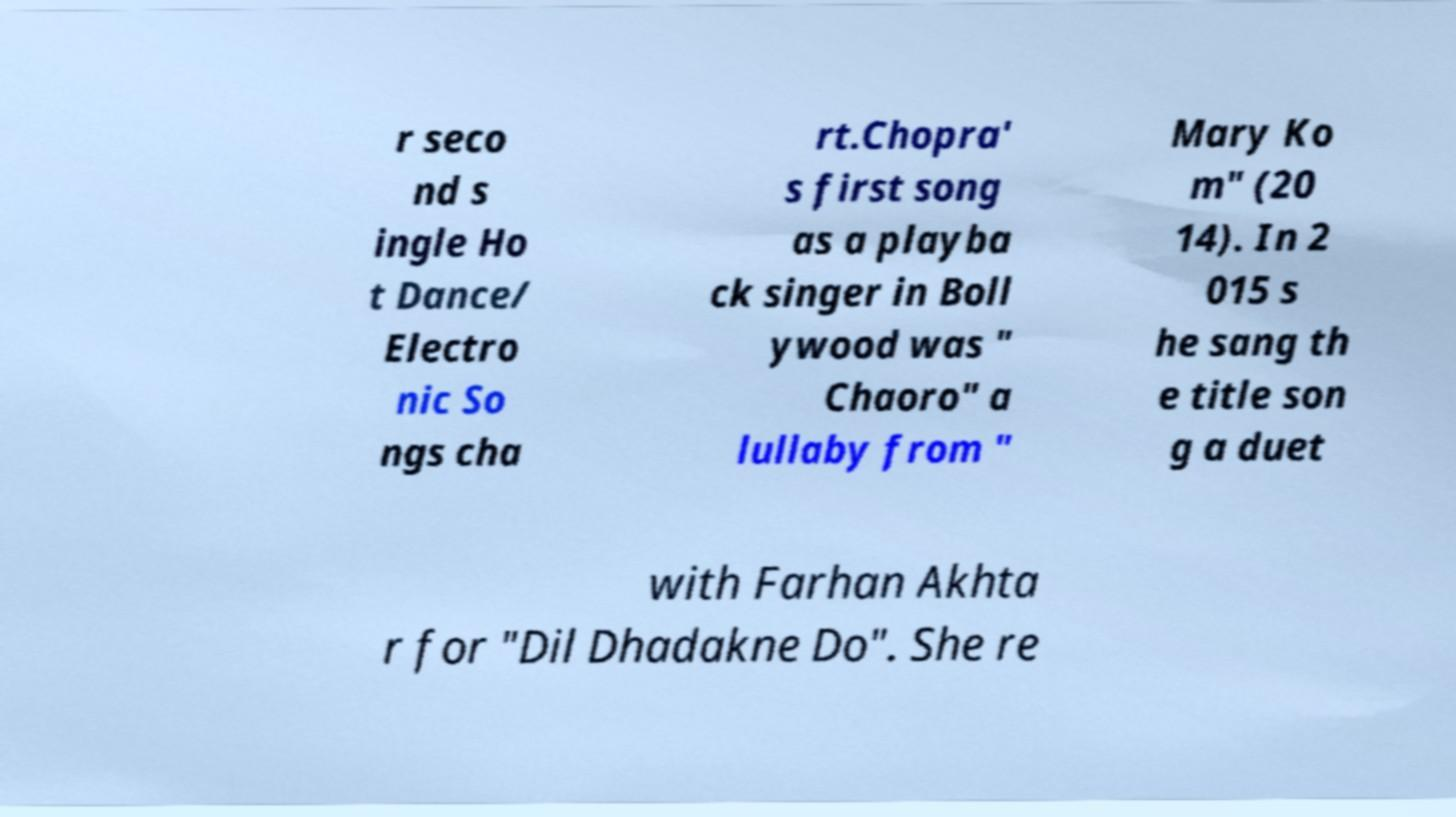Could you assist in decoding the text presented in this image and type it out clearly? r seco nd s ingle Ho t Dance/ Electro nic So ngs cha rt.Chopra' s first song as a playba ck singer in Boll ywood was " Chaoro" a lullaby from " Mary Ko m" (20 14). In 2 015 s he sang th e title son g a duet with Farhan Akhta r for "Dil Dhadakne Do". She re 